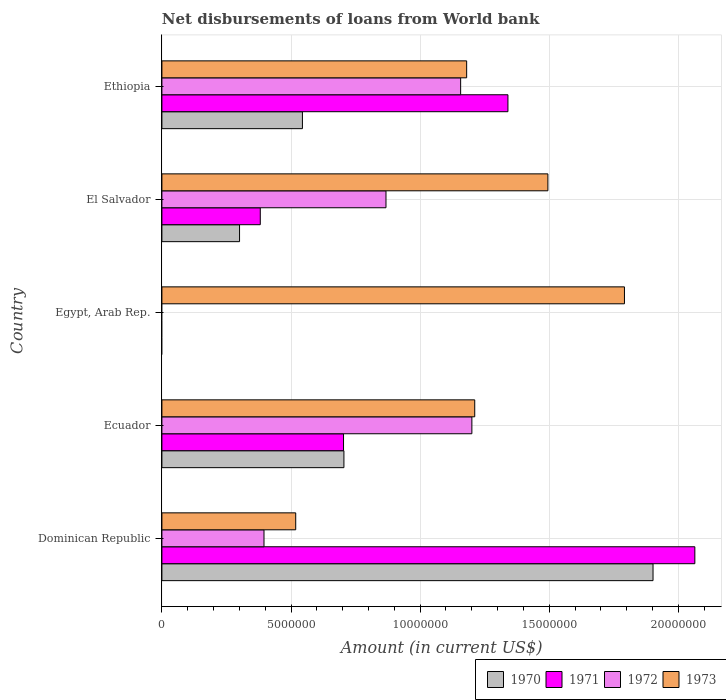How many different coloured bars are there?
Ensure brevity in your answer.  4. How many bars are there on the 4th tick from the top?
Provide a succinct answer. 4. How many bars are there on the 3rd tick from the bottom?
Provide a succinct answer. 1. What is the label of the 2nd group of bars from the top?
Make the answer very short. El Salvador. In how many cases, is the number of bars for a given country not equal to the number of legend labels?
Your answer should be very brief. 1. What is the amount of loan disbursed from World Bank in 1972 in Ecuador?
Your answer should be very brief. 1.20e+07. Across all countries, what is the maximum amount of loan disbursed from World Bank in 1973?
Give a very brief answer. 1.79e+07. Across all countries, what is the minimum amount of loan disbursed from World Bank in 1972?
Make the answer very short. 0. In which country was the amount of loan disbursed from World Bank in 1970 maximum?
Your answer should be very brief. Dominican Republic. What is the total amount of loan disbursed from World Bank in 1970 in the graph?
Your answer should be very brief. 3.45e+07. What is the difference between the amount of loan disbursed from World Bank in 1971 in Dominican Republic and that in El Salvador?
Offer a very short reply. 1.68e+07. What is the difference between the amount of loan disbursed from World Bank in 1971 in Ecuador and the amount of loan disbursed from World Bank in 1973 in El Salvador?
Offer a terse response. -7.91e+06. What is the average amount of loan disbursed from World Bank in 1971 per country?
Offer a terse response. 8.98e+06. What is the difference between the amount of loan disbursed from World Bank in 1971 and amount of loan disbursed from World Bank in 1972 in Dominican Republic?
Keep it short and to the point. 1.67e+07. In how many countries, is the amount of loan disbursed from World Bank in 1973 greater than 8000000 US$?
Give a very brief answer. 4. What is the ratio of the amount of loan disbursed from World Bank in 1971 in Ecuador to that in Ethiopia?
Your response must be concise. 0.52. Is the amount of loan disbursed from World Bank in 1971 in Dominican Republic less than that in Ecuador?
Provide a short and direct response. No. Is the difference between the amount of loan disbursed from World Bank in 1971 in Ecuador and El Salvador greater than the difference between the amount of loan disbursed from World Bank in 1972 in Ecuador and El Salvador?
Offer a terse response. No. What is the difference between the highest and the second highest amount of loan disbursed from World Bank in 1971?
Your answer should be very brief. 7.24e+06. What is the difference between the highest and the lowest amount of loan disbursed from World Bank in 1970?
Your response must be concise. 1.90e+07. Is it the case that in every country, the sum of the amount of loan disbursed from World Bank in 1970 and amount of loan disbursed from World Bank in 1972 is greater than the sum of amount of loan disbursed from World Bank in 1971 and amount of loan disbursed from World Bank in 1973?
Ensure brevity in your answer.  No. Is it the case that in every country, the sum of the amount of loan disbursed from World Bank in 1970 and amount of loan disbursed from World Bank in 1973 is greater than the amount of loan disbursed from World Bank in 1972?
Offer a very short reply. Yes. How many countries are there in the graph?
Your response must be concise. 5. Are the values on the major ticks of X-axis written in scientific E-notation?
Keep it short and to the point. No. Does the graph contain any zero values?
Give a very brief answer. Yes. Where does the legend appear in the graph?
Your answer should be compact. Bottom right. How many legend labels are there?
Provide a succinct answer. 4. What is the title of the graph?
Provide a succinct answer. Net disbursements of loans from World bank. What is the label or title of the X-axis?
Ensure brevity in your answer.  Amount (in current US$). What is the label or title of the Y-axis?
Offer a terse response. Country. What is the Amount (in current US$) in 1970 in Dominican Republic?
Your response must be concise. 1.90e+07. What is the Amount (in current US$) of 1971 in Dominican Republic?
Give a very brief answer. 2.06e+07. What is the Amount (in current US$) in 1972 in Dominican Republic?
Make the answer very short. 3.95e+06. What is the Amount (in current US$) in 1973 in Dominican Republic?
Provide a short and direct response. 5.18e+06. What is the Amount (in current US$) of 1970 in Ecuador?
Offer a very short reply. 7.05e+06. What is the Amount (in current US$) in 1971 in Ecuador?
Offer a very short reply. 7.03e+06. What is the Amount (in current US$) of 1972 in Ecuador?
Offer a very short reply. 1.20e+07. What is the Amount (in current US$) in 1973 in Ecuador?
Offer a very short reply. 1.21e+07. What is the Amount (in current US$) of 1970 in Egypt, Arab Rep.?
Give a very brief answer. 0. What is the Amount (in current US$) of 1972 in Egypt, Arab Rep.?
Your response must be concise. 0. What is the Amount (in current US$) of 1973 in Egypt, Arab Rep.?
Your answer should be very brief. 1.79e+07. What is the Amount (in current US$) of 1970 in El Salvador?
Provide a short and direct response. 3.01e+06. What is the Amount (in current US$) in 1971 in El Salvador?
Make the answer very short. 3.81e+06. What is the Amount (in current US$) in 1972 in El Salvador?
Ensure brevity in your answer.  8.68e+06. What is the Amount (in current US$) in 1973 in El Salvador?
Your answer should be compact. 1.49e+07. What is the Amount (in current US$) of 1970 in Ethiopia?
Ensure brevity in your answer.  5.44e+06. What is the Amount (in current US$) of 1971 in Ethiopia?
Provide a short and direct response. 1.34e+07. What is the Amount (in current US$) in 1972 in Ethiopia?
Make the answer very short. 1.16e+07. What is the Amount (in current US$) in 1973 in Ethiopia?
Offer a very short reply. 1.18e+07. Across all countries, what is the maximum Amount (in current US$) in 1970?
Ensure brevity in your answer.  1.90e+07. Across all countries, what is the maximum Amount (in current US$) in 1971?
Offer a terse response. 2.06e+07. Across all countries, what is the maximum Amount (in current US$) in 1972?
Your answer should be compact. 1.20e+07. Across all countries, what is the maximum Amount (in current US$) in 1973?
Ensure brevity in your answer.  1.79e+07. Across all countries, what is the minimum Amount (in current US$) in 1970?
Provide a succinct answer. 0. Across all countries, what is the minimum Amount (in current US$) in 1971?
Offer a terse response. 0. Across all countries, what is the minimum Amount (in current US$) in 1972?
Offer a terse response. 0. Across all countries, what is the minimum Amount (in current US$) in 1973?
Make the answer very short. 5.18e+06. What is the total Amount (in current US$) in 1970 in the graph?
Your answer should be very brief. 3.45e+07. What is the total Amount (in current US$) in 1971 in the graph?
Give a very brief answer. 4.49e+07. What is the total Amount (in current US$) in 1972 in the graph?
Give a very brief answer. 3.62e+07. What is the total Amount (in current US$) in 1973 in the graph?
Your answer should be compact. 6.20e+07. What is the difference between the Amount (in current US$) in 1970 in Dominican Republic and that in Ecuador?
Provide a short and direct response. 1.20e+07. What is the difference between the Amount (in current US$) in 1971 in Dominican Republic and that in Ecuador?
Offer a very short reply. 1.36e+07. What is the difference between the Amount (in current US$) of 1972 in Dominican Republic and that in Ecuador?
Provide a short and direct response. -8.05e+06. What is the difference between the Amount (in current US$) of 1973 in Dominican Republic and that in Ecuador?
Your response must be concise. -6.93e+06. What is the difference between the Amount (in current US$) in 1973 in Dominican Republic and that in Egypt, Arab Rep.?
Your answer should be very brief. -1.27e+07. What is the difference between the Amount (in current US$) of 1970 in Dominican Republic and that in El Salvador?
Ensure brevity in your answer.  1.60e+07. What is the difference between the Amount (in current US$) in 1971 in Dominican Republic and that in El Salvador?
Provide a succinct answer. 1.68e+07. What is the difference between the Amount (in current US$) in 1972 in Dominican Republic and that in El Salvador?
Offer a terse response. -4.72e+06. What is the difference between the Amount (in current US$) of 1973 in Dominican Republic and that in El Salvador?
Your answer should be compact. -9.77e+06. What is the difference between the Amount (in current US$) of 1970 in Dominican Republic and that in Ethiopia?
Your response must be concise. 1.36e+07. What is the difference between the Amount (in current US$) in 1971 in Dominican Republic and that in Ethiopia?
Keep it short and to the point. 7.24e+06. What is the difference between the Amount (in current US$) in 1972 in Dominican Republic and that in Ethiopia?
Give a very brief answer. -7.62e+06. What is the difference between the Amount (in current US$) of 1973 in Dominican Republic and that in Ethiopia?
Your response must be concise. -6.62e+06. What is the difference between the Amount (in current US$) of 1973 in Ecuador and that in Egypt, Arab Rep.?
Provide a short and direct response. -5.80e+06. What is the difference between the Amount (in current US$) of 1970 in Ecuador and that in El Salvador?
Ensure brevity in your answer.  4.04e+06. What is the difference between the Amount (in current US$) of 1971 in Ecuador and that in El Salvador?
Keep it short and to the point. 3.22e+06. What is the difference between the Amount (in current US$) of 1972 in Ecuador and that in El Salvador?
Your response must be concise. 3.33e+06. What is the difference between the Amount (in current US$) of 1973 in Ecuador and that in El Salvador?
Your response must be concise. -2.83e+06. What is the difference between the Amount (in current US$) in 1970 in Ecuador and that in Ethiopia?
Your answer should be very brief. 1.61e+06. What is the difference between the Amount (in current US$) of 1971 in Ecuador and that in Ethiopia?
Offer a very short reply. -6.37e+06. What is the difference between the Amount (in current US$) in 1972 in Ecuador and that in Ethiopia?
Give a very brief answer. 4.35e+05. What is the difference between the Amount (in current US$) in 1973 in Ecuador and that in Ethiopia?
Offer a very short reply. 3.13e+05. What is the difference between the Amount (in current US$) in 1973 in Egypt, Arab Rep. and that in El Salvador?
Offer a terse response. 2.96e+06. What is the difference between the Amount (in current US$) of 1973 in Egypt, Arab Rep. and that in Ethiopia?
Provide a succinct answer. 6.11e+06. What is the difference between the Amount (in current US$) of 1970 in El Salvador and that in Ethiopia?
Your answer should be very brief. -2.44e+06. What is the difference between the Amount (in current US$) of 1971 in El Salvador and that in Ethiopia?
Your answer should be very brief. -9.59e+06. What is the difference between the Amount (in current US$) of 1972 in El Salvador and that in Ethiopia?
Give a very brief answer. -2.89e+06. What is the difference between the Amount (in current US$) in 1973 in El Salvador and that in Ethiopia?
Your answer should be very brief. 3.15e+06. What is the difference between the Amount (in current US$) in 1970 in Dominican Republic and the Amount (in current US$) in 1971 in Ecuador?
Make the answer very short. 1.20e+07. What is the difference between the Amount (in current US$) of 1970 in Dominican Republic and the Amount (in current US$) of 1972 in Ecuador?
Give a very brief answer. 7.02e+06. What is the difference between the Amount (in current US$) in 1970 in Dominican Republic and the Amount (in current US$) in 1973 in Ecuador?
Make the answer very short. 6.90e+06. What is the difference between the Amount (in current US$) in 1971 in Dominican Republic and the Amount (in current US$) in 1972 in Ecuador?
Offer a very short reply. 8.64e+06. What is the difference between the Amount (in current US$) in 1971 in Dominican Republic and the Amount (in current US$) in 1973 in Ecuador?
Offer a very short reply. 8.52e+06. What is the difference between the Amount (in current US$) of 1972 in Dominican Republic and the Amount (in current US$) of 1973 in Ecuador?
Give a very brief answer. -8.16e+06. What is the difference between the Amount (in current US$) of 1970 in Dominican Republic and the Amount (in current US$) of 1973 in Egypt, Arab Rep.?
Keep it short and to the point. 1.11e+06. What is the difference between the Amount (in current US$) in 1971 in Dominican Republic and the Amount (in current US$) in 1973 in Egypt, Arab Rep.?
Provide a succinct answer. 2.73e+06. What is the difference between the Amount (in current US$) in 1972 in Dominican Republic and the Amount (in current US$) in 1973 in Egypt, Arab Rep.?
Offer a terse response. -1.40e+07. What is the difference between the Amount (in current US$) of 1970 in Dominican Republic and the Amount (in current US$) of 1971 in El Salvador?
Ensure brevity in your answer.  1.52e+07. What is the difference between the Amount (in current US$) in 1970 in Dominican Republic and the Amount (in current US$) in 1972 in El Salvador?
Provide a short and direct response. 1.03e+07. What is the difference between the Amount (in current US$) of 1970 in Dominican Republic and the Amount (in current US$) of 1973 in El Salvador?
Make the answer very short. 4.07e+06. What is the difference between the Amount (in current US$) in 1971 in Dominican Republic and the Amount (in current US$) in 1972 in El Salvador?
Make the answer very short. 1.20e+07. What is the difference between the Amount (in current US$) of 1971 in Dominican Republic and the Amount (in current US$) of 1973 in El Salvador?
Ensure brevity in your answer.  5.69e+06. What is the difference between the Amount (in current US$) of 1972 in Dominican Republic and the Amount (in current US$) of 1973 in El Salvador?
Your answer should be very brief. -1.10e+07. What is the difference between the Amount (in current US$) of 1970 in Dominican Republic and the Amount (in current US$) of 1971 in Ethiopia?
Make the answer very short. 5.62e+06. What is the difference between the Amount (in current US$) in 1970 in Dominican Republic and the Amount (in current US$) in 1972 in Ethiopia?
Offer a terse response. 7.45e+06. What is the difference between the Amount (in current US$) in 1970 in Dominican Republic and the Amount (in current US$) in 1973 in Ethiopia?
Provide a succinct answer. 7.22e+06. What is the difference between the Amount (in current US$) in 1971 in Dominican Republic and the Amount (in current US$) in 1972 in Ethiopia?
Your response must be concise. 9.07e+06. What is the difference between the Amount (in current US$) in 1971 in Dominican Republic and the Amount (in current US$) in 1973 in Ethiopia?
Keep it short and to the point. 8.84e+06. What is the difference between the Amount (in current US$) in 1972 in Dominican Republic and the Amount (in current US$) in 1973 in Ethiopia?
Your response must be concise. -7.85e+06. What is the difference between the Amount (in current US$) in 1970 in Ecuador and the Amount (in current US$) in 1973 in Egypt, Arab Rep.?
Provide a succinct answer. -1.09e+07. What is the difference between the Amount (in current US$) in 1971 in Ecuador and the Amount (in current US$) in 1973 in Egypt, Arab Rep.?
Your answer should be compact. -1.09e+07. What is the difference between the Amount (in current US$) in 1972 in Ecuador and the Amount (in current US$) in 1973 in Egypt, Arab Rep.?
Provide a short and direct response. -5.91e+06. What is the difference between the Amount (in current US$) in 1970 in Ecuador and the Amount (in current US$) in 1971 in El Salvador?
Keep it short and to the point. 3.24e+06. What is the difference between the Amount (in current US$) in 1970 in Ecuador and the Amount (in current US$) in 1972 in El Salvador?
Ensure brevity in your answer.  -1.63e+06. What is the difference between the Amount (in current US$) of 1970 in Ecuador and the Amount (in current US$) of 1973 in El Salvador?
Make the answer very short. -7.90e+06. What is the difference between the Amount (in current US$) of 1971 in Ecuador and the Amount (in current US$) of 1972 in El Salvador?
Your response must be concise. -1.64e+06. What is the difference between the Amount (in current US$) of 1971 in Ecuador and the Amount (in current US$) of 1973 in El Salvador?
Ensure brevity in your answer.  -7.91e+06. What is the difference between the Amount (in current US$) of 1972 in Ecuador and the Amount (in current US$) of 1973 in El Salvador?
Give a very brief answer. -2.94e+06. What is the difference between the Amount (in current US$) in 1970 in Ecuador and the Amount (in current US$) in 1971 in Ethiopia?
Provide a succinct answer. -6.35e+06. What is the difference between the Amount (in current US$) of 1970 in Ecuador and the Amount (in current US$) of 1972 in Ethiopia?
Ensure brevity in your answer.  -4.52e+06. What is the difference between the Amount (in current US$) of 1970 in Ecuador and the Amount (in current US$) of 1973 in Ethiopia?
Keep it short and to the point. -4.75e+06. What is the difference between the Amount (in current US$) in 1971 in Ecuador and the Amount (in current US$) in 1972 in Ethiopia?
Keep it short and to the point. -4.54e+06. What is the difference between the Amount (in current US$) of 1971 in Ecuador and the Amount (in current US$) of 1973 in Ethiopia?
Provide a short and direct response. -4.77e+06. What is the difference between the Amount (in current US$) in 1972 in Ecuador and the Amount (in current US$) in 1973 in Ethiopia?
Your answer should be compact. 2.02e+05. What is the difference between the Amount (in current US$) of 1970 in El Salvador and the Amount (in current US$) of 1971 in Ethiopia?
Give a very brief answer. -1.04e+07. What is the difference between the Amount (in current US$) in 1970 in El Salvador and the Amount (in current US$) in 1972 in Ethiopia?
Offer a terse response. -8.56e+06. What is the difference between the Amount (in current US$) in 1970 in El Salvador and the Amount (in current US$) in 1973 in Ethiopia?
Provide a succinct answer. -8.80e+06. What is the difference between the Amount (in current US$) of 1971 in El Salvador and the Amount (in current US$) of 1972 in Ethiopia?
Provide a succinct answer. -7.76e+06. What is the difference between the Amount (in current US$) of 1971 in El Salvador and the Amount (in current US$) of 1973 in Ethiopia?
Give a very brief answer. -7.99e+06. What is the difference between the Amount (in current US$) in 1972 in El Salvador and the Amount (in current US$) in 1973 in Ethiopia?
Give a very brief answer. -3.12e+06. What is the average Amount (in current US$) of 1970 per country?
Provide a short and direct response. 6.90e+06. What is the average Amount (in current US$) in 1971 per country?
Make the answer very short. 8.98e+06. What is the average Amount (in current US$) in 1972 per country?
Your response must be concise. 7.24e+06. What is the average Amount (in current US$) of 1973 per country?
Your answer should be very brief. 1.24e+07. What is the difference between the Amount (in current US$) of 1970 and Amount (in current US$) of 1971 in Dominican Republic?
Ensure brevity in your answer.  -1.62e+06. What is the difference between the Amount (in current US$) in 1970 and Amount (in current US$) in 1972 in Dominican Republic?
Your answer should be compact. 1.51e+07. What is the difference between the Amount (in current US$) of 1970 and Amount (in current US$) of 1973 in Dominican Republic?
Your answer should be compact. 1.38e+07. What is the difference between the Amount (in current US$) of 1971 and Amount (in current US$) of 1972 in Dominican Republic?
Offer a very short reply. 1.67e+07. What is the difference between the Amount (in current US$) of 1971 and Amount (in current US$) of 1973 in Dominican Republic?
Keep it short and to the point. 1.55e+07. What is the difference between the Amount (in current US$) of 1972 and Amount (in current US$) of 1973 in Dominican Republic?
Your answer should be compact. -1.23e+06. What is the difference between the Amount (in current US$) of 1970 and Amount (in current US$) of 1971 in Ecuador?
Keep it short and to the point. 1.50e+04. What is the difference between the Amount (in current US$) in 1970 and Amount (in current US$) in 1972 in Ecuador?
Provide a succinct answer. -4.96e+06. What is the difference between the Amount (in current US$) in 1970 and Amount (in current US$) in 1973 in Ecuador?
Offer a very short reply. -5.07e+06. What is the difference between the Amount (in current US$) of 1971 and Amount (in current US$) of 1972 in Ecuador?
Make the answer very short. -4.97e+06. What is the difference between the Amount (in current US$) in 1971 and Amount (in current US$) in 1973 in Ecuador?
Offer a very short reply. -5.08e+06. What is the difference between the Amount (in current US$) of 1972 and Amount (in current US$) of 1973 in Ecuador?
Your answer should be compact. -1.11e+05. What is the difference between the Amount (in current US$) in 1970 and Amount (in current US$) in 1971 in El Salvador?
Ensure brevity in your answer.  -8.03e+05. What is the difference between the Amount (in current US$) in 1970 and Amount (in current US$) in 1972 in El Salvador?
Offer a terse response. -5.67e+06. What is the difference between the Amount (in current US$) in 1970 and Amount (in current US$) in 1973 in El Salvador?
Ensure brevity in your answer.  -1.19e+07. What is the difference between the Amount (in current US$) of 1971 and Amount (in current US$) of 1972 in El Salvador?
Give a very brief answer. -4.87e+06. What is the difference between the Amount (in current US$) in 1971 and Amount (in current US$) in 1973 in El Salvador?
Offer a very short reply. -1.11e+07. What is the difference between the Amount (in current US$) of 1972 and Amount (in current US$) of 1973 in El Salvador?
Provide a short and direct response. -6.27e+06. What is the difference between the Amount (in current US$) in 1970 and Amount (in current US$) in 1971 in Ethiopia?
Your response must be concise. -7.96e+06. What is the difference between the Amount (in current US$) of 1970 and Amount (in current US$) of 1972 in Ethiopia?
Offer a terse response. -6.13e+06. What is the difference between the Amount (in current US$) of 1970 and Amount (in current US$) of 1973 in Ethiopia?
Your response must be concise. -6.36e+06. What is the difference between the Amount (in current US$) of 1971 and Amount (in current US$) of 1972 in Ethiopia?
Give a very brief answer. 1.83e+06. What is the difference between the Amount (in current US$) in 1971 and Amount (in current US$) in 1973 in Ethiopia?
Provide a succinct answer. 1.60e+06. What is the difference between the Amount (in current US$) of 1972 and Amount (in current US$) of 1973 in Ethiopia?
Your answer should be compact. -2.33e+05. What is the ratio of the Amount (in current US$) of 1970 in Dominican Republic to that in Ecuador?
Provide a short and direct response. 2.7. What is the ratio of the Amount (in current US$) in 1971 in Dominican Republic to that in Ecuador?
Your answer should be compact. 2.93. What is the ratio of the Amount (in current US$) of 1972 in Dominican Republic to that in Ecuador?
Your answer should be very brief. 0.33. What is the ratio of the Amount (in current US$) in 1973 in Dominican Republic to that in Ecuador?
Offer a very short reply. 0.43. What is the ratio of the Amount (in current US$) of 1973 in Dominican Republic to that in Egypt, Arab Rep.?
Your answer should be very brief. 0.29. What is the ratio of the Amount (in current US$) of 1970 in Dominican Republic to that in El Salvador?
Offer a terse response. 6.33. What is the ratio of the Amount (in current US$) of 1971 in Dominican Republic to that in El Salvador?
Your answer should be compact. 5.42. What is the ratio of the Amount (in current US$) of 1972 in Dominican Republic to that in El Salvador?
Ensure brevity in your answer.  0.46. What is the ratio of the Amount (in current US$) in 1973 in Dominican Republic to that in El Salvador?
Ensure brevity in your answer.  0.35. What is the ratio of the Amount (in current US$) in 1970 in Dominican Republic to that in Ethiopia?
Ensure brevity in your answer.  3.5. What is the ratio of the Amount (in current US$) in 1971 in Dominican Republic to that in Ethiopia?
Offer a very short reply. 1.54. What is the ratio of the Amount (in current US$) of 1972 in Dominican Republic to that in Ethiopia?
Ensure brevity in your answer.  0.34. What is the ratio of the Amount (in current US$) in 1973 in Dominican Republic to that in Ethiopia?
Provide a succinct answer. 0.44. What is the ratio of the Amount (in current US$) of 1973 in Ecuador to that in Egypt, Arab Rep.?
Provide a succinct answer. 0.68. What is the ratio of the Amount (in current US$) of 1970 in Ecuador to that in El Salvador?
Offer a terse response. 2.34. What is the ratio of the Amount (in current US$) in 1971 in Ecuador to that in El Salvador?
Offer a terse response. 1.85. What is the ratio of the Amount (in current US$) in 1972 in Ecuador to that in El Salvador?
Make the answer very short. 1.38. What is the ratio of the Amount (in current US$) of 1973 in Ecuador to that in El Salvador?
Offer a very short reply. 0.81. What is the ratio of the Amount (in current US$) of 1970 in Ecuador to that in Ethiopia?
Your answer should be very brief. 1.3. What is the ratio of the Amount (in current US$) of 1971 in Ecuador to that in Ethiopia?
Your answer should be compact. 0.52. What is the ratio of the Amount (in current US$) in 1972 in Ecuador to that in Ethiopia?
Provide a succinct answer. 1.04. What is the ratio of the Amount (in current US$) of 1973 in Ecuador to that in Ethiopia?
Your answer should be very brief. 1.03. What is the ratio of the Amount (in current US$) of 1973 in Egypt, Arab Rep. to that in El Salvador?
Your answer should be very brief. 1.2. What is the ratio of the Amount (in current US$) of 1973 in Egypt, Arab Rep. to that in Ethiopia?
Provide a succinct answer. 1.52. What is the ratio of the Amount (in current US$) of 1970 in El Salvador to that in Ethiopia?
Provide a short and direct response. 0.55. What is the ratio of the Amount (in current US$) in 1971 in El Salvador to that in Ethiopia?
Offer a very short reply. 0.28. What is the ratio of the Amount (in current US$) of 1972 in El Salvador to that in Ethiopia?
Give a very brief answer. 0.75. What is the ratio of the Amount (in current US$) of 1973 in El Salvador to that in Ethiopia?
Your response must be concise. 1.27. What is the difference between the highest and the second highest Amount (in current US$) in 1970?
Keep it short and to the point. 1.20e+07. What is the difference between the highest and the second highest Amount (in current US$) of 1971?
Provide a succinct answer. 7.24e+06. What is the difference between the highest and the second highest Amount (in current US$) of 1972?
Provide a succinct answer. 4.35e+05. What is the difference between the highest and the second highest Amount (in current US$) in 1973?
Make the answer very short. 2.96e+06. What is the difference between the highest and the lowest Amount (in current US$) in 1970?
Your response must be concise. 1.90e+07. What is the difference between the highest and the lowest Amount (in current US$) of 1971?
Your answer should be compact. 2.06e+07. What is the difference between the highest and the lowest Amount (in current US$) in 1972?
Offer a terse response. 1.20e+07. What is the difference between the highest and the lowest Amount (in current US$) of 1973?
Provide a short and direct response. 1.27e+07. 